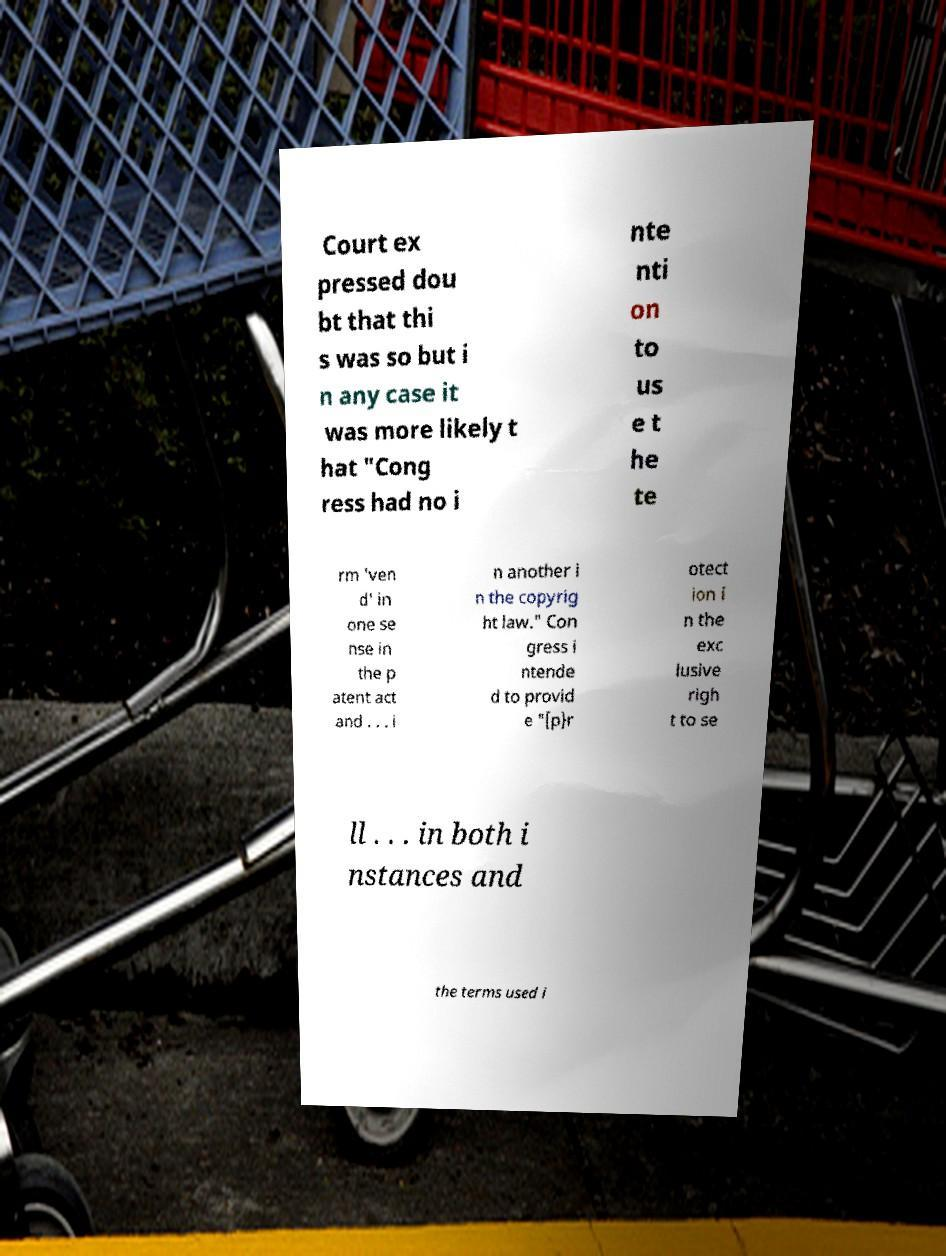Please identify and transcribe the text found in this image. Court ex pressed dou bt that thi s was so but i n any case it was more likely t hat "Cong ress had no i nte nti on to us e t he te rm 'ven d' in one se nse in the p atent act and . . . i n another i n the copyrig ht law." Con gress i ntende d to provid e "[p}r otect ion i n the exc lusive righ t to se ll . . . in both i nstances and the terms used i 